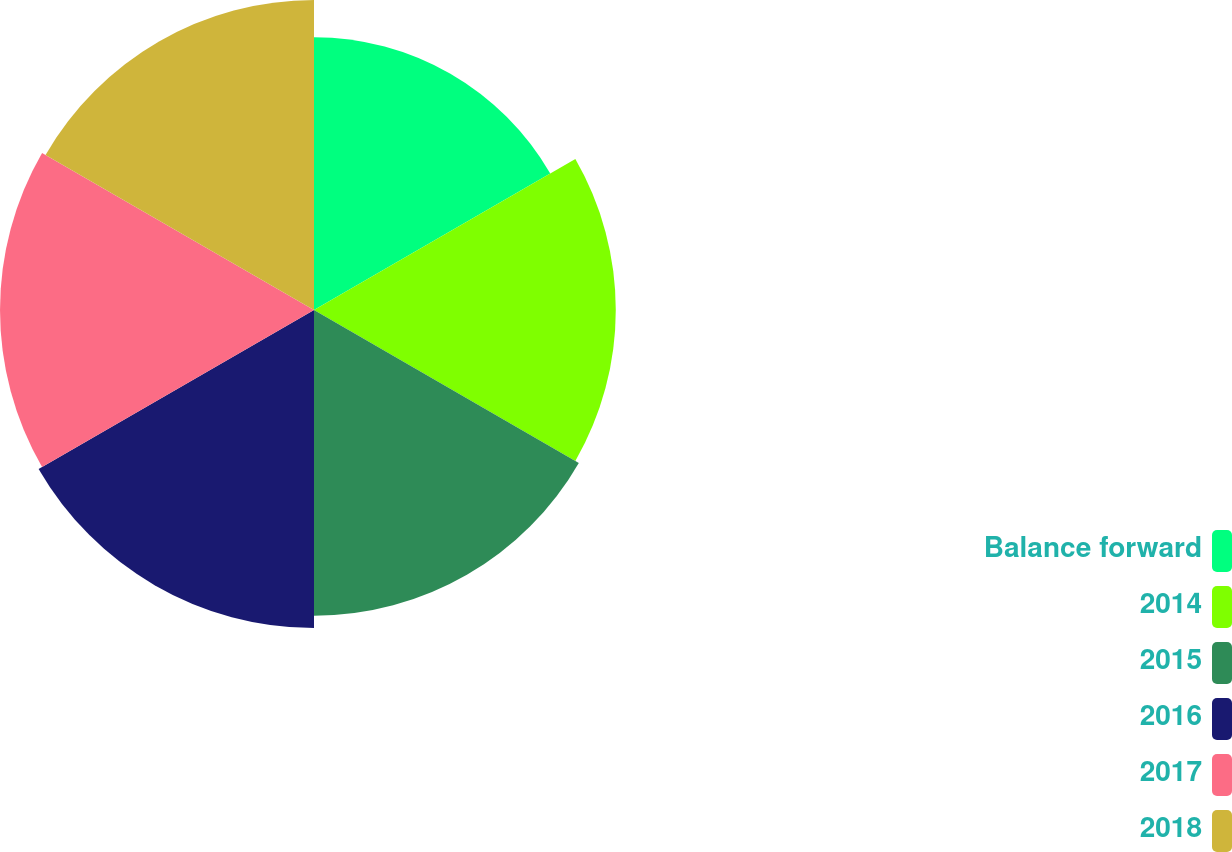<chart> <loc_0><loc_0><loc_500><loc_500><pie_chart><fcel>Balance forward<fcel>2014<fcel>2015<fcel>2016<fcel>2017<fcel>2018<nl><fcel>14.97%<fcel>16.56%<fcel>16.78%<fcel>17.45%<fcel>17.23%<fcel>17.01%<nl></chart> 